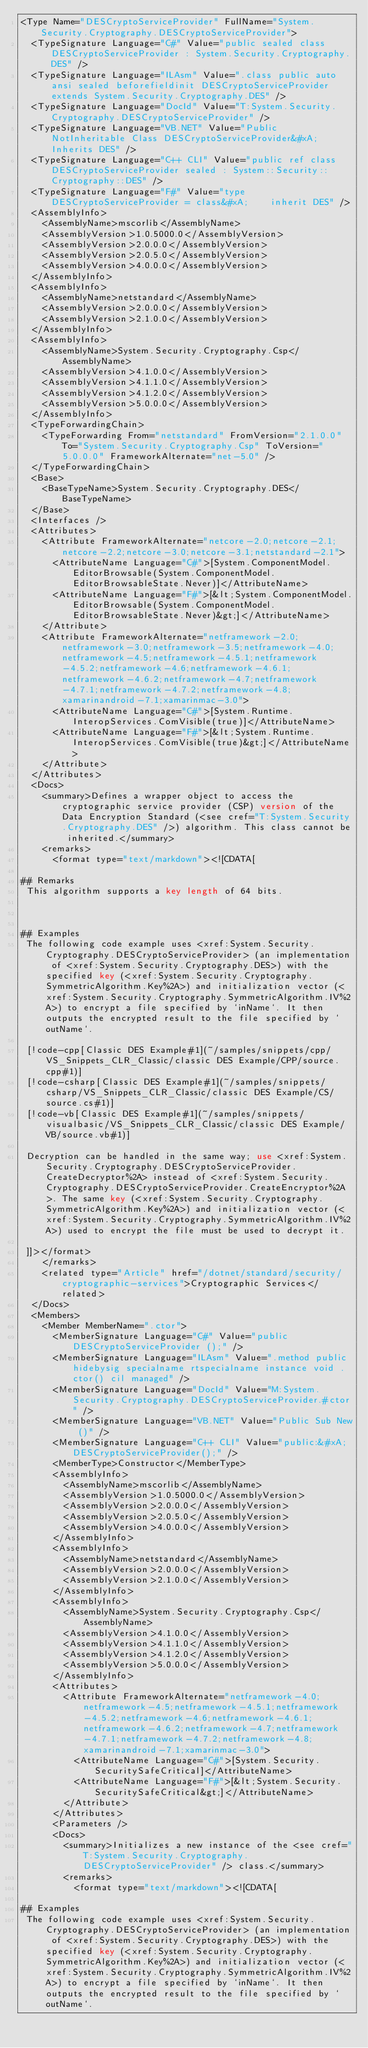Convert code to text. <code><loc_0><loc_0><loc_500><loc_500><_XML_><Type Name="DESCryptoServiceProvider" FullName="System.Security.Cryptography.DESCryptoServiceProvider">
  <TypeSignature Language="C#" Value="public sealed class DESCryptoServiceProvider : System.Security.Cryptography.DES" />
  <TypeSignature Language="ILAsm" Value=".class public auto ansi sealed beforefieldinit DESCryptoServiceProvider extends System.Security.Cryptography.DES" />
  <TypeSignature Language="DocId" Value="T:System.Security.Cryptography.DESCryptoServiceProvider" />
  <TypeSignature Language="VB.NET" Value="Public NotInheritable Class DESCryptoServiceProvider&#xA;Inherits DES" />
  <TypeSignature Language="C++ CLI" Value="public ref class DESCryptoServiceProvider sealed : System::Security::Cryptography::DES" />
  <TypeSignature Language="F#" Value="type DESCryptoServiceProvider = class&#xA;    inherit DES" />
  <AssemblyInfo>
    <AssemblyName>mscorlib</AssemblyName>
    <AssemblyVersion>1.0.5000.0</AssemblyVersion>
    <AssemblyVersion>2.0.0.0</AssemblyVersion>
    <AssemblyVersion>2.0.5.0</AssemblyVersion>
    <AssemblyVersion>4.0.0.0</AssemblyVersion>
  </AssemblyInfo>
  <AssemblyInfo>
    <AssemblyName>netstandard</AssemblyName>
    <AssemblyVersion>2.0.0.0</AssemblyVersion>
    <AssemblyVersion>2.1.0.0</AssemblyVersion>
  </AssemblyInfo>
  <AssemblyInfo>
    <AssemblyName>System.Security.Cryptography.Csp</AssemblyName>
    <AssemblyVersion>4.1.0.0</AssemblyVersion>
    <AssemblyVersion>4.1.1.0</AssemblyVersion>
    <AssemblyVersion>4.1.2.0</AssemblyVersion>
    <AssemblyVersion>5.0.0.0</AssemblyVersion>
  </AssemblyInfo>
  <TypeForwardingChain>
    <TypeForwarding From="netstandard" FromVersion="2.1.0.0" To="System.Security.Cryptography.Csp" ToVersion="5.0.0.0" FrameworkAlternate="net-5.0" />
  </TypeForwardingChain>
  <Base>
    <BaseTypeName>System.Security.Cryptography.DES</BaseTypeName>
  </Base>
  <Interfaces />
  <Attributes>
    <Attribute FrameworkAlternate="netcore-2.0;netcore-2.1;netcore-2.2;netcore-3.0;netcore-3.1;netstandard-2.1">
      <AttributeName Language="C#">[System.ComponentModel.EditorBrowsable(System.ComponentModel.EditorBrowsableState.Never)]</AttributeName>
      <AttributeName Language="F#">[&lt;System.ComponentModel.EditorBrowsable(System.ComponentModel.EditorBrowsableState.Never)&gt;]</AttributeName>
    </Attribute>
    <Attribute FrameworkAlternate="netframework-2.0;netframework-3.0;netframework-3.5;netframework-4.0;netframework-4.5;netframework-4.5.1;netframework-4.5.2;netframework-4.6;netframework-4.6.1;netframework-4.6.2;netframework-4.7;netframework-4.7.1;netframework-4.7.2;netframework-4.8;xamarinandroid-7.1;xamarinmac-3.0">
      <AttributeName Language="C#">[System.Runtime.InteropServices.ComVisible(true)]</AttributeName>
      <AttributeName Language="F#">[&lt;System.Runtime.InteropServices.ComVisible(true)&gt;]</AttributeName>
    </Attribute>
  </Attributes>
  <Docs>
    <summary>Defines a wrapper object to access the cryptographic service provider (CSP) version of the Data Encryption Standard (<see cref="T:System.Security.Cryptography.DES" />) algorithm. This class cannot be inherited.</summary>
    <remarks>
      <format type="text/markdown"><![CDATA[  
  
## Remarks  
 This algorithm supports a key length of 64 bits.  
  
   
  
## Examples  
 The following code example uses <xref:System.Security.Cryptography.DESCryptoServiceProvider> (an implementation of <xref:System.Security.Cryptography.DES>) with the specified key (<xref:System.Security.Cryptography.SymmetricAlgorithm.Key%2A>) and initialization vector (<xref:System.Security.Cryptography.SymmetricAlgorithm.IV%2A>) to encrypt a file specified by `inName`. It then outputs the encrypted result to the file specified by `outName`.  
  
 [!code-cpp[Classic DES Example#1](~/samples/snippets/cpp/VS_Snippets_CLR_Classic/classic DES Example/CPP/source.cpp#1)]
 [!code-csharp[Classic DES Example#1](~/samples/snippets/csharp/VS_Snippets_CLR_Classic/classic DES Example/CS/source.cs#1)]
 [!code-vb[Classic DES Example#1](~/samples/snippets/visualbasic/VS_Snippets_CLR_Classic/classic DES Example/VB/source.vb#1)]  
  
 Decryption can be handled in the same way; use <xref:System.Security.Cryptography.DESCryptoServiceProvider.CreateDecryptor%2A> instead of <xref:System.Security.Cryptography.DESCryptoServiceProvider.CreateEncryptor%2A>. The same key (<xref:System.Security.Cryptography.SymmetricAlgorithm.Key%2A>) and initialization vector (<xref:System.Security.Cryptography.SymmetricAlgorithm.IV%2A>) used to encrypt the file must be used to decrypt it.  
  
 ]]></format>
    </remarks>
    <related type="Article" href="/dotnet/standard/security/cryptographic-services">Cryptographic Services</related>
  </Docs>
  <Members>
    <Member MemberName=".ctor">
      <MemberSignature Language="C#" Value="public DESCryptoServiceProvider ();" />
      <MemberSignature Language="ILAsm" Value=".method public hidebysig specialname rtspecialname instance void .ctor() cil managed" />
      <MemberSignature Language="DocId" Value="M:System.Security.Cryptography.DESCryptoServiceProvider.#ctor" />
      <MemberSignature Language="VB.NET" Value="Public Sub New ()" />
      <MemberSignature Language="C++ CLI" Value="public:&#xA; DESCryptoServiceProvider();" />
      <MemberType>Constructor</MemberType>
      <AssemblyInfo>
        <AssemblyName>mscorlib</AssemblyName>
        <AssemblyVersion>1.0.5000.0</AssemblyVersion>
        <AssemblyVersion>2.0.0.0</AssemblyVersion>
        <AssemblyVersion>2.0.5.0</AssemblyVersion>
        <AssemblyVersion>4.0.0.0</AssemblyVersion>
      </AssemblyInfo>
      <AssemblyInfo>
        <AssemblyName>netstandard</AssemblyName>
        <AssemblyVersion>2.0.0.0</AssemblyVersion>
        <AssemblyVersion>2.1.0.0</AssemblyVersion>
      </AssemblyInfo>
      <AssemblyInfo>
        <AssemblyName>System.Security.Cryptography.Csp</AssemblyName>
        <AssemblyVersion>4.1.0.0</AssemblyVersion>
        <AssemblyVersion>4.1.1.0</AssemblyVersion>
        <AssemblyVersion>4.1.2.0</AssemblyVersion>
        <AssemblyVersion>5.0.0.0</AssemblyVersion>
      </AssemblyInfo>
      <Attributes>
        <Attribute FrameworkAlternate="netframework-4.0;netframework-4.5;netframework-4.5.1;netframework-4.5.2;netframework-4.6;netframework-4.6.1;netframework-4.6.2;netframework-4.7;netframework-4.7.1;netframework-4.7.2;netframework-4.8;xamarinandroid-7.1;xamarinmac-3.0">
          <AttributeName Language="C#">[System.Security.SecuritySafeCritical]</AttributeName>
          <AttributeName Language="F#">[&lt;System.Security.SecuritySafeCritical&gt;]</AttributeName>
        </Attribute>
      </Attributes>
      <Parameters />
      <Docs>
        <summary>Initializes a new instance of the <see cref="T:System.Security.Cryptography.DESCryptoServiceProvider" /> class.</summary>
        <remarks>
          <format type="text/markdown"><![CDATA[  
  
## Examples  
 The following code example uses <xref:System.Security.Cryptography.DESCryptoServiceProvider> (an implementation of <xref:System.Security.Cryptography.DES>) with the specified key (<xref:System.Security.Cryptography.SymmetricAlgorithm.Key%2A>) and initialization vector (<xref:System.Security.Cryptography.SymmetricAlgorithm.IV%2A>) to encrypt a file specified by `inName`. It then outputs the encrypted result to the file specified by `outName`.  
  </code> 